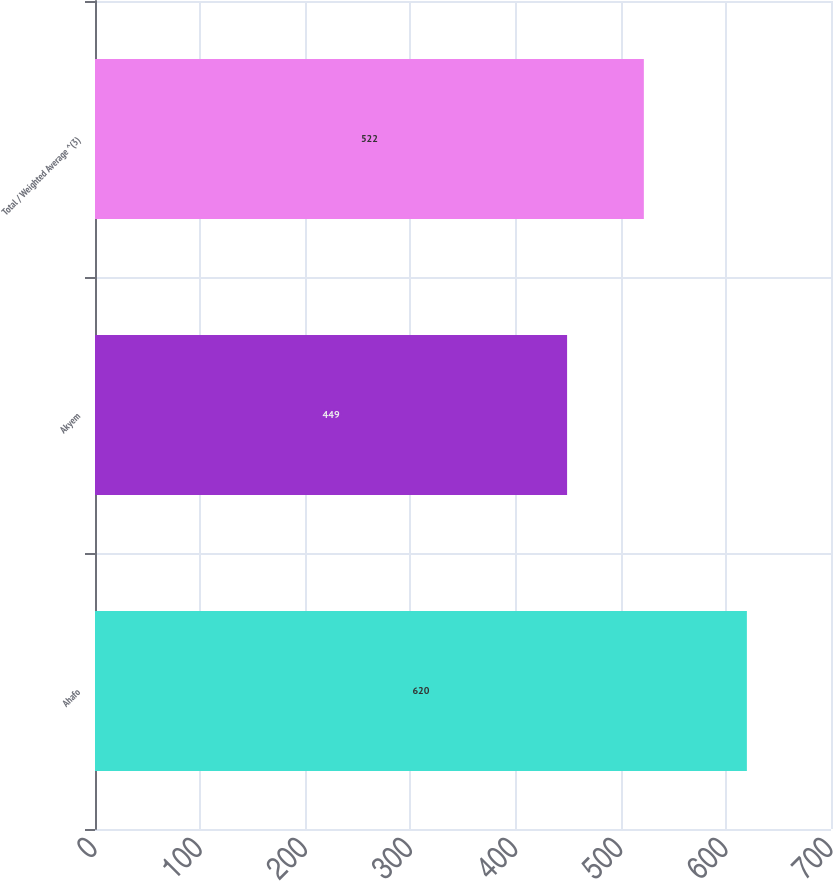Convert chart. <chart><loc_0><loc_0><loc_500><loc_500><bar_chart><fcel>Ahafo<fcel>Akyem<fcel>Total / Weighted Average ^(3)<nl><fcel>620<fcel>449<fcel>522<nl></chart> 